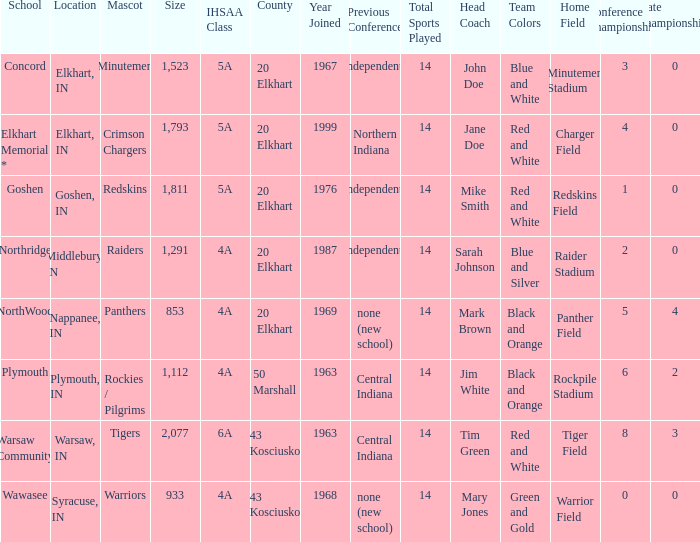What is the size of the team that was previously from Central Indiana conference, and is in IHSSA Class 4a? 1112.0. 